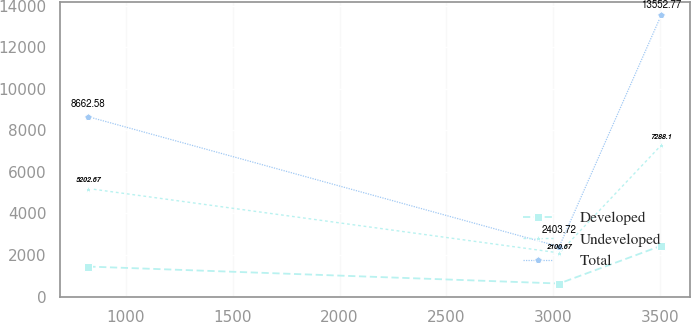Convert chart. <chart><loc_0><loc_0><loc_500><loc_500><line_chart><ecel><fcel>Developed<fcel>Undeveloped<fcel>Total<nl><fcel>823.47<fcel>1443.45<fcel>5202.67<fcel>8662.58<nl><fcel>3028.38<fcel>626.21<fcel>2100.67<fcel>2403.72<nl><fcel>3505.49<fcel>2444.03<fcel>7288.1<fcel>13552.8<nl></chart> 